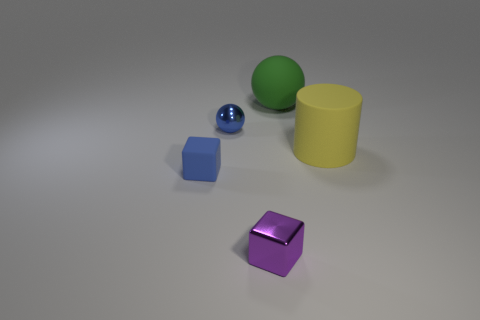There is a cylinder that is the same size as the green ball; what is its color?
Offer a terse response. Yellow. There is a metallic thing that is in front of the tiny metallic ball; what size is it?
Give a very brief answer. Small. There is a rubber thing behind the yellow cylinder; are there any large matte things to the right of it?
Keep it short and to the point. Yes. Is the large object that is behind the yellow rubber cylinder made of the same material as the purple cube?
Give a very brief answer. No. What number of objects are both right of the small metal cube and left of the purple block?
Your answer should be very brief. 0. What number of green balls are made of the same material as the cylinder?
Make the answer very short. 1. What is the color of the tiny block that is made of the same material as the big cylinder?
Your answer should be very brief. Blue. Is the number of yellow metallic cylinders less than the number of tiny cubes?
Your answer should be very brief. Yes. What is the material of the sphere that is right of the ball that is on the left side of the shiny object that is in front of the blue metallic object?
Keep it short and to the point. Rubber. What is the blue cube made of?
Give a very brief answer. Rubber. 